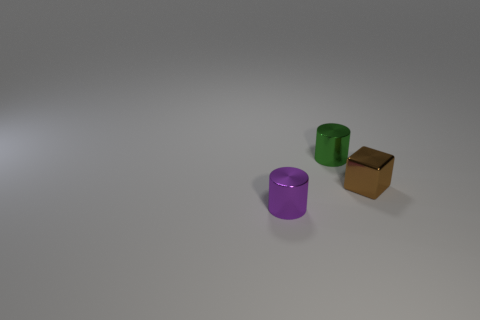Is there a purple cylinder that is to the left of the tiny metallic cylinder that is in front of the thing right of the green shiny thing?
Ensure brevity in your answer.  No. Do the object that is behind the small cube and the object in front of the brown thing have the same material?
Make the answer very short. Yes. What number of objects are either small shiny cylinders or shiny things to the right of the small green cylinder?
Offer a terse response. 3. How many green things are the same shape as the tiny brown object?
Your response must be concise. 0. There is a brown block that is the same size as the purple shiny thing; what material is it?
Your response must be concise. Metal. How big is the brown thing that is in front of the cylinder that is behind the tiny shiny cylinder in front of the block?
Ensure brevity in your answer.  Small. Do the object behind the small brown metallic block and the object in front of the brown thing have the same color?
Keep it short and to the point. No. What number of gray objects are either tiny cubes or metal cylinders?
Provide a succinct answer. 0. How many green cylinders have the same size as the brown object?
Offer a terse response. 1. Is the small cube to the right of the small purple object made of the same material as the small purple object?
Ensure brevity in your answer.  Yes. 